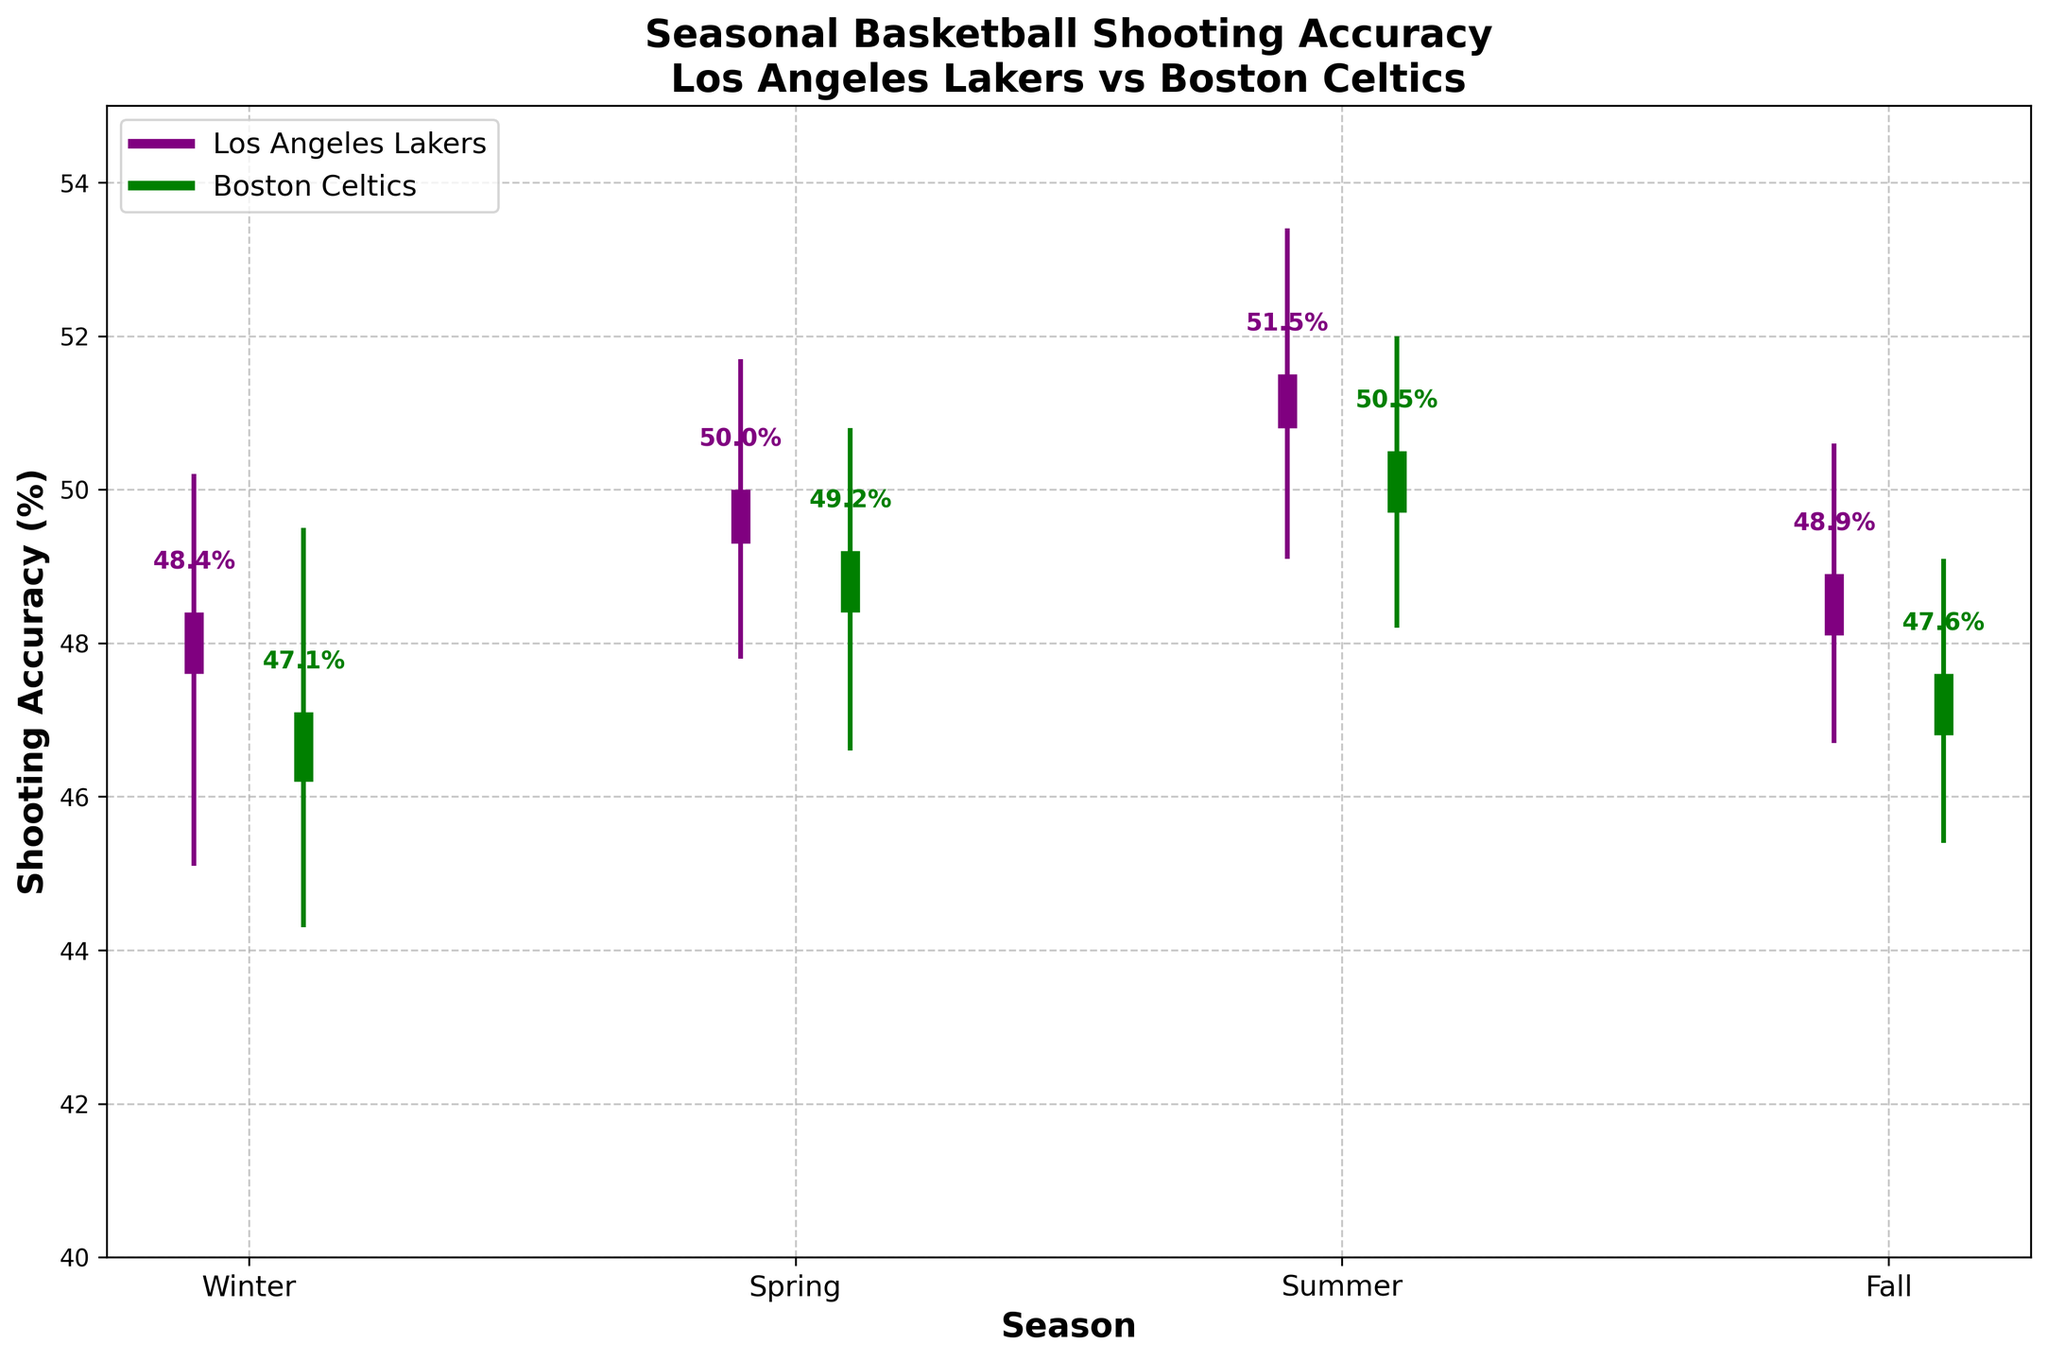What's the title of the figure? The title is clearly displayed at the top of the figure. It describes the content of the plot.
Answer: Seasonal Basketball Shooting Accuracy\nLos Angeles Lakers vs Boston Celtics What are the color representations for the two teams? The figure uses color coding to differentiate data. The Los Angeles Lakers are shown in purple, and the Boston Celtics in green.
Answer: Purple for Lakers, Green for Celtics What is the shooting accuracy range for the Los Angeles Lakers in the Winter? To find this, look at the candlestick for Winter marked in purple. The lower end (low) is 45.1% and the upper end (high) is 50.2%.
Answer: 45.1% to 50.2% Which season shows the highest shooting accuracy for both teams? By comparing the high values of each candlestick, Summer has the highest values for both teams. Lakers' high is 53.4%, and Celtics' high is 52.0%.
Answer: Summer What is the difference between the closing shooting accuracy of the Lakers and Celtics in Spring? Subtract the Celtics' closing value from the Lakers' closing value for Spring. Lakers close at 50.0% and Celtics close at 49.2%. So, the difference is 50.0% - 49.2%.
Answer: 0.8% What season has the smallest difference between the high and low shooting accuracy for the Celtics? Calculate the differences for the Celtics in each season and find the smallest. Winter: 49.5% - 44.3% = 5.2%, Spring: 50.8% - 46.6% = 4.2%, Summer: 52.0% - 48.2% = 3.8%, Fall: 49.1% - 45.4% = 3.7%. The smallest difference is in Fall.
Answer: Fall How did the Lakers' shooting accuracy change from Spring to Summer? Compare the shooting accuracy values for the Lakers between the two seasons. The high increases from 51.7% in Spring to 53.4% in Summer, and the close increases from 50.0% to 51.5%.
Answer: Increased Which team had a higher opening shooting accuracy in Fall? Look at the Fall candlestick's open values for both teams. Lakers opened at 48.1% and Celtics opened at 46.8%. Lakers had a higher opening accuracy.
Answer: Lakers During which season did the Celtics have their highest closing shooting accuracy? Compare the closing values for the Celtics in all seasons. Winter: 47.1%, Spring: 49.2%, Summer: 50.5%, Fall: 47.6%. The highest is in Summer.
Answer: Summer What is the overall trend in shooting accuracy for the Lakers from Winter to Fall? Track the high and closing values for the Lakers from Winter, Spring, Summer, to Fall to observe the trend. Winter (high 50.2%, close 48.4%), Spring (51.7%, 50.0%), Summer (53.4%, 51.5%), Fall (50.6%, 48.9%). The trend shows an increase during Spring and Summer, followed by a decrease in Fall.
Answer: Increases then decreases 